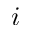<formula> <loc_0><loc_0><loc_500><loc_500>i</formula> 